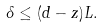Convert formula to latex. <formula><loc_0><loc_0><loc_500><loc_500>\delta \leq ( d - z ) L .</formula> 